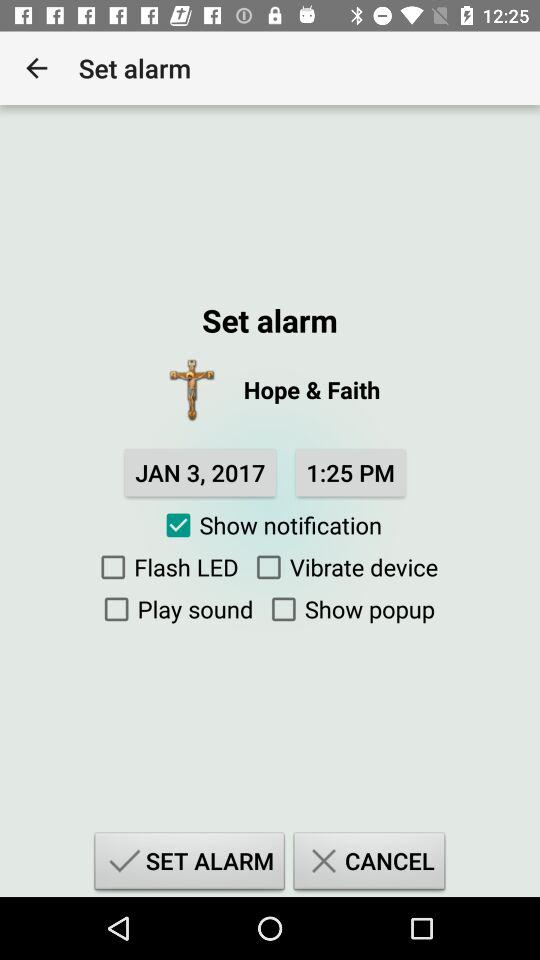What is the status of "Show notification"? The status of "Show notification" is "on". 